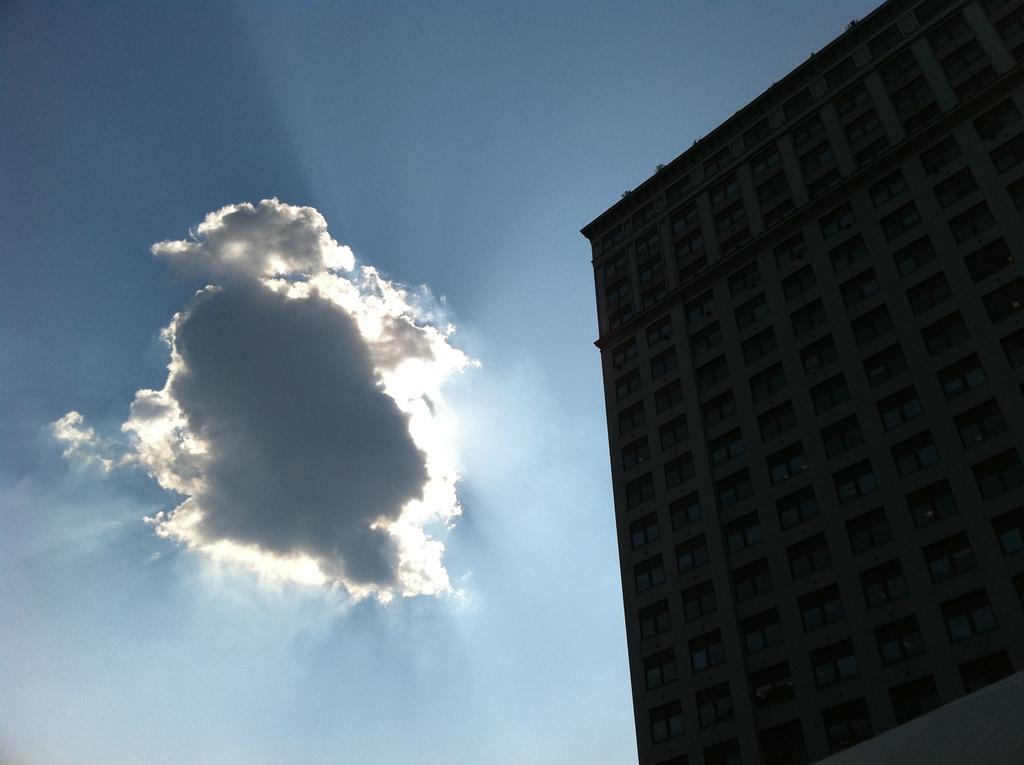Could you give a brief overview of what you see in this image? In this image I can see the sky and on the right side I can see the building. 